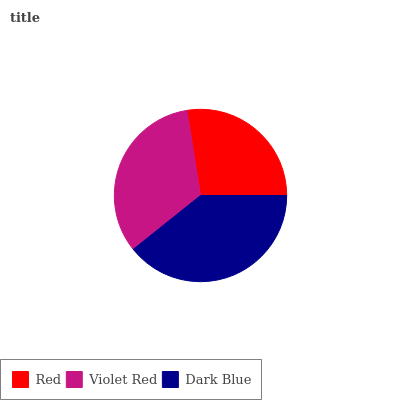Is Red the minimum?
Answer yes or no. Yes. Is Dark Blue the maximum?
Answer yes or no. Yes. Is Violet Red the minimum?
Answer yes or no. No. Is Violet Red the maximum?
Answer yes or no. No. Is Violet Red greater than Red?
Answer yes or no. Yes. Is Red less than Violet Red?
Answer yes or no. Yes. Is Red greater than Violet Red?
Answer yes or no. No. Is Violet Red less than Red?
Answer yes or no. No. Is Violet Red the high median?
Answer yes or no. Yes. Is Violet Red the low median?
Answer yes or no. Yes. Is Dark Blue the high median?
Answer yes or no. No. Is Red the low median?
Answer yes or no. No. 